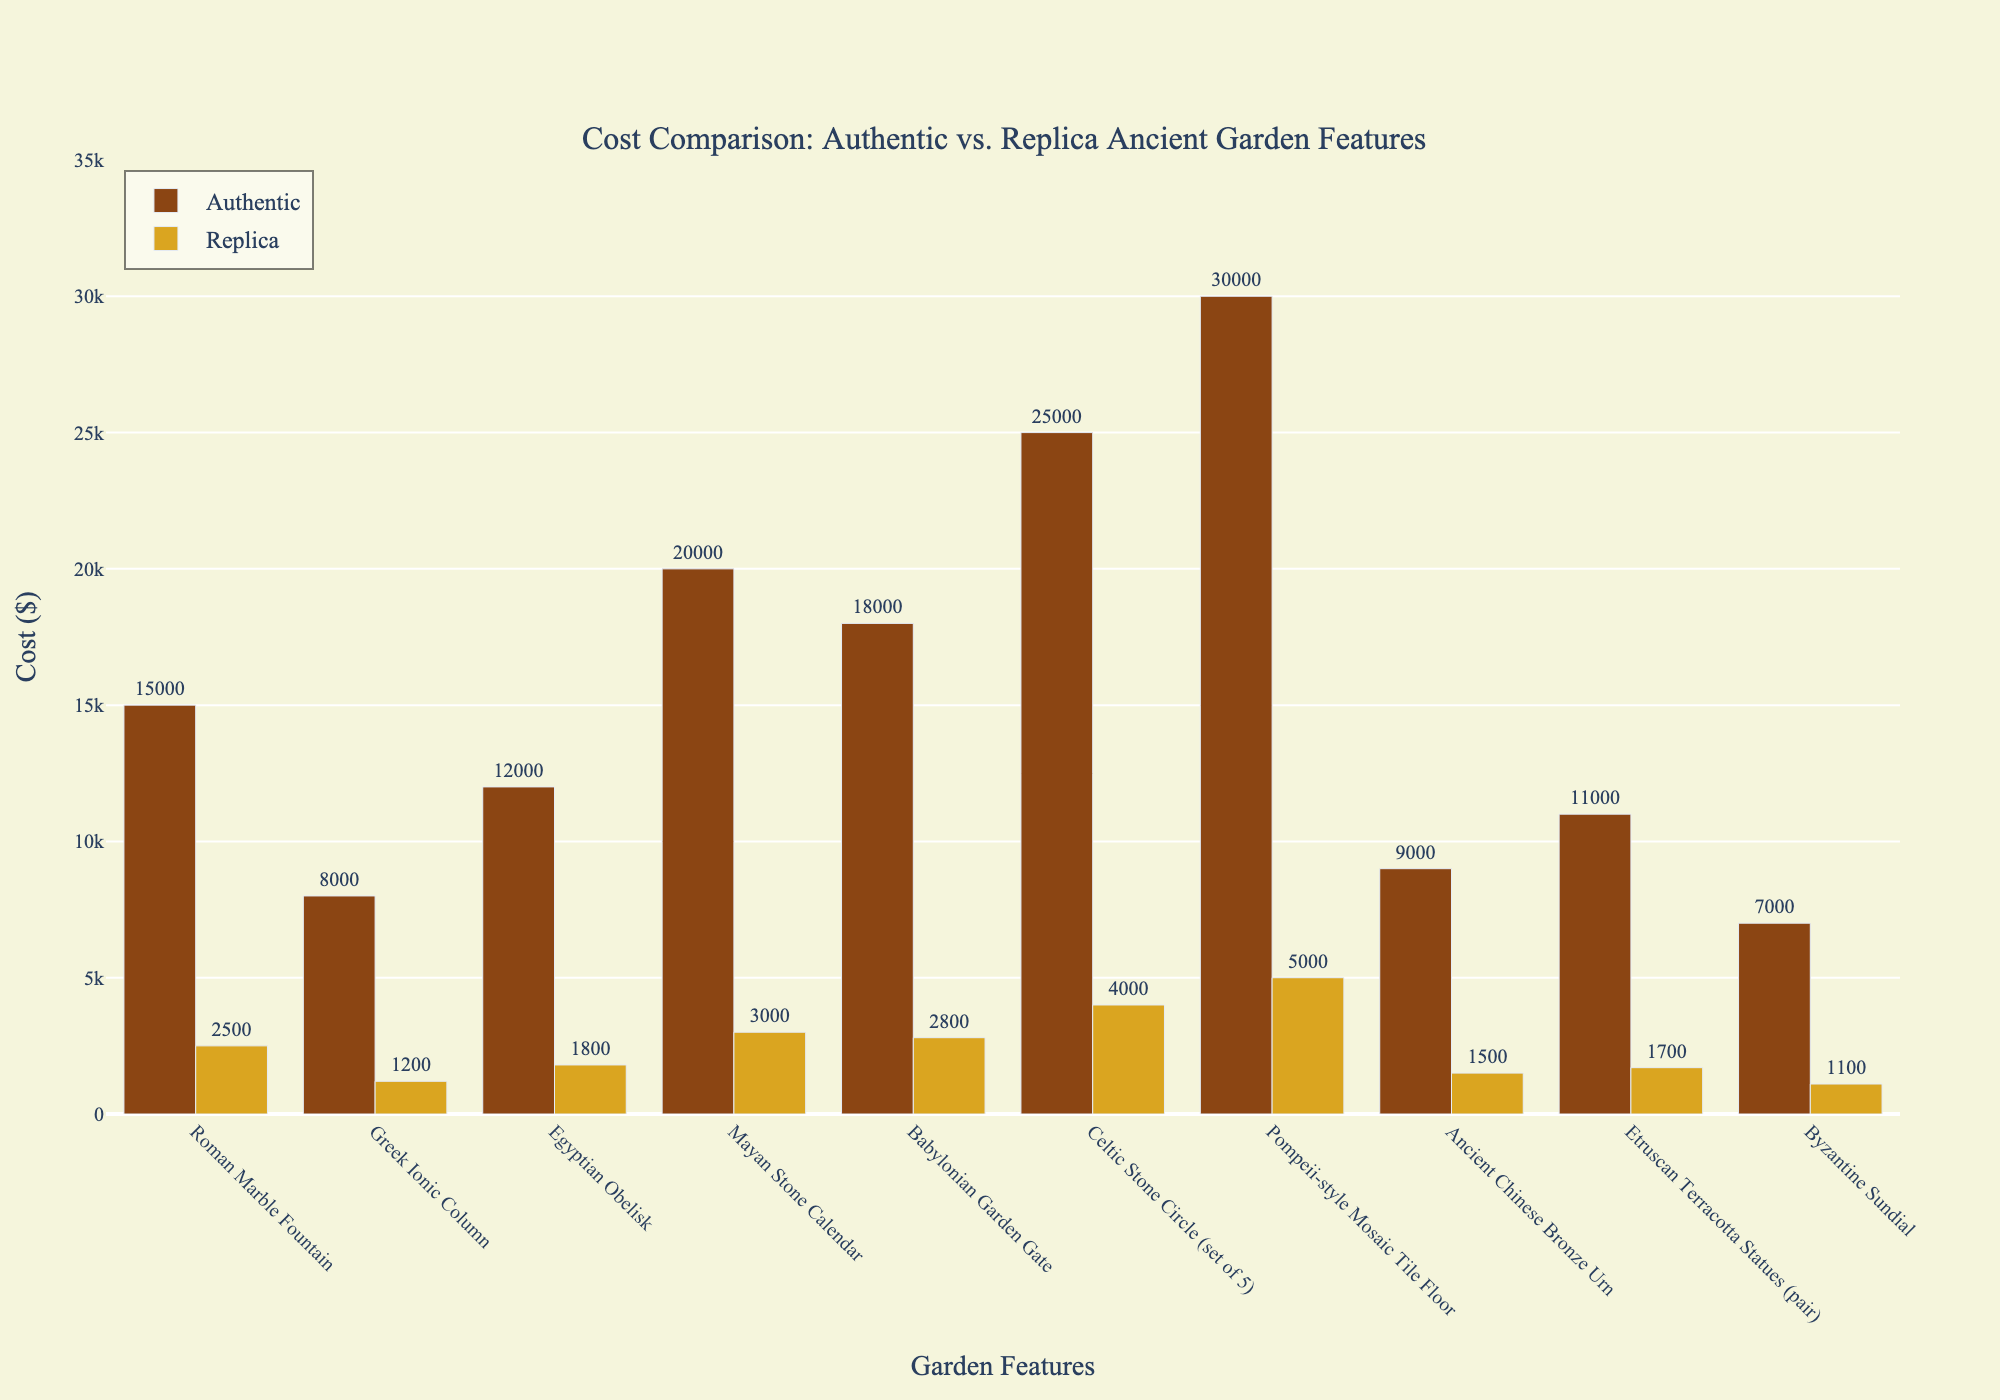Which item has the highest authentic cost? Look at the height of the bars within the authentic series and identify the tallest one. The "Pompeii-style Mosaic Tile Floor" bar is the tallest, indicating it has the highest cost.
Answer: Pompeii-style Mosaic Tile Floor What is the cost difference between the authentic and replica Mayan Stone Calendar? Refer to the heights of the bars for "Mayan Stone Calendar" in both the authentic and replica series. Subtract the height of the replica bar ($3000) from the height of the authentic bar ($20000).
Answer: $17000 Which item has the smallest cost difference between its authentic and replica versions? Compare the differences between each pair of bars. The "Byzantine Sundial" has the smallest difference: $7000 (authentic) - $1100 (replica) = $5900.
Answer: Byzantine Sundial How many items have an authentic cost that is more than five times the replica cost? Compare the heights of bars from the authentic series to those in the replica series. Count the instances where the authentic cost is more than five times the replica cost. These items are “Roman Marble Fountain” ($15000 vs. $2500), “Greek Ionic Column” ($8000 vs. $1200), “Egyptian Obelisk” ($12000 vs. $1800), “Mayan Stone Calendar” ($20000 vs. $3000), and “Ancient Chinese Bronze Urn” ($9000 vs. $1500).
Answer: 5 Which authentic item has a cost closest to $10,000? Identify the heights of the bars in the authentic series and check which one is near $10,000. The "Ancient Chinese Bronze Urn" with $9000 is closest to this value.
Answer: Ancient Chinese Bronze Urn Compare the total cost of all authentic items to the total cost of all replica items. Sum the heights of all bars in the authentic series and the replica series respectively. Authentic: $15000 + $8000 + $12000 + $20000 + $18000 + $25000 + $30000 + $9000 + $11000 + $7000 = $155000. Replica: $2500 + $1200 + $1800 + $3000 + $2800 + $4000 + $5000 + $1500 + $1700 + $1100 = $24600.
Answer: Authentic: $155000, Replica: $24600 Which item shows the greatest relative difference between authentic and replica costs? Calculate the relative difference for each item: (Authentic Cost - Replica Cost) / Authentic Cost. The "Greek Ionic Column": (8000 - 1200) / 8000 = 0.85, which represents the highest relative difference.
Answer: Greek Ionic Column What is the average cost of the replica items? Sum the heights of the bars in the replica series and divide by the number of items. Total Replica Cost: $24600. Number of items: 10. Average = $24600 / 10 = $2460.
Answer: $2460 